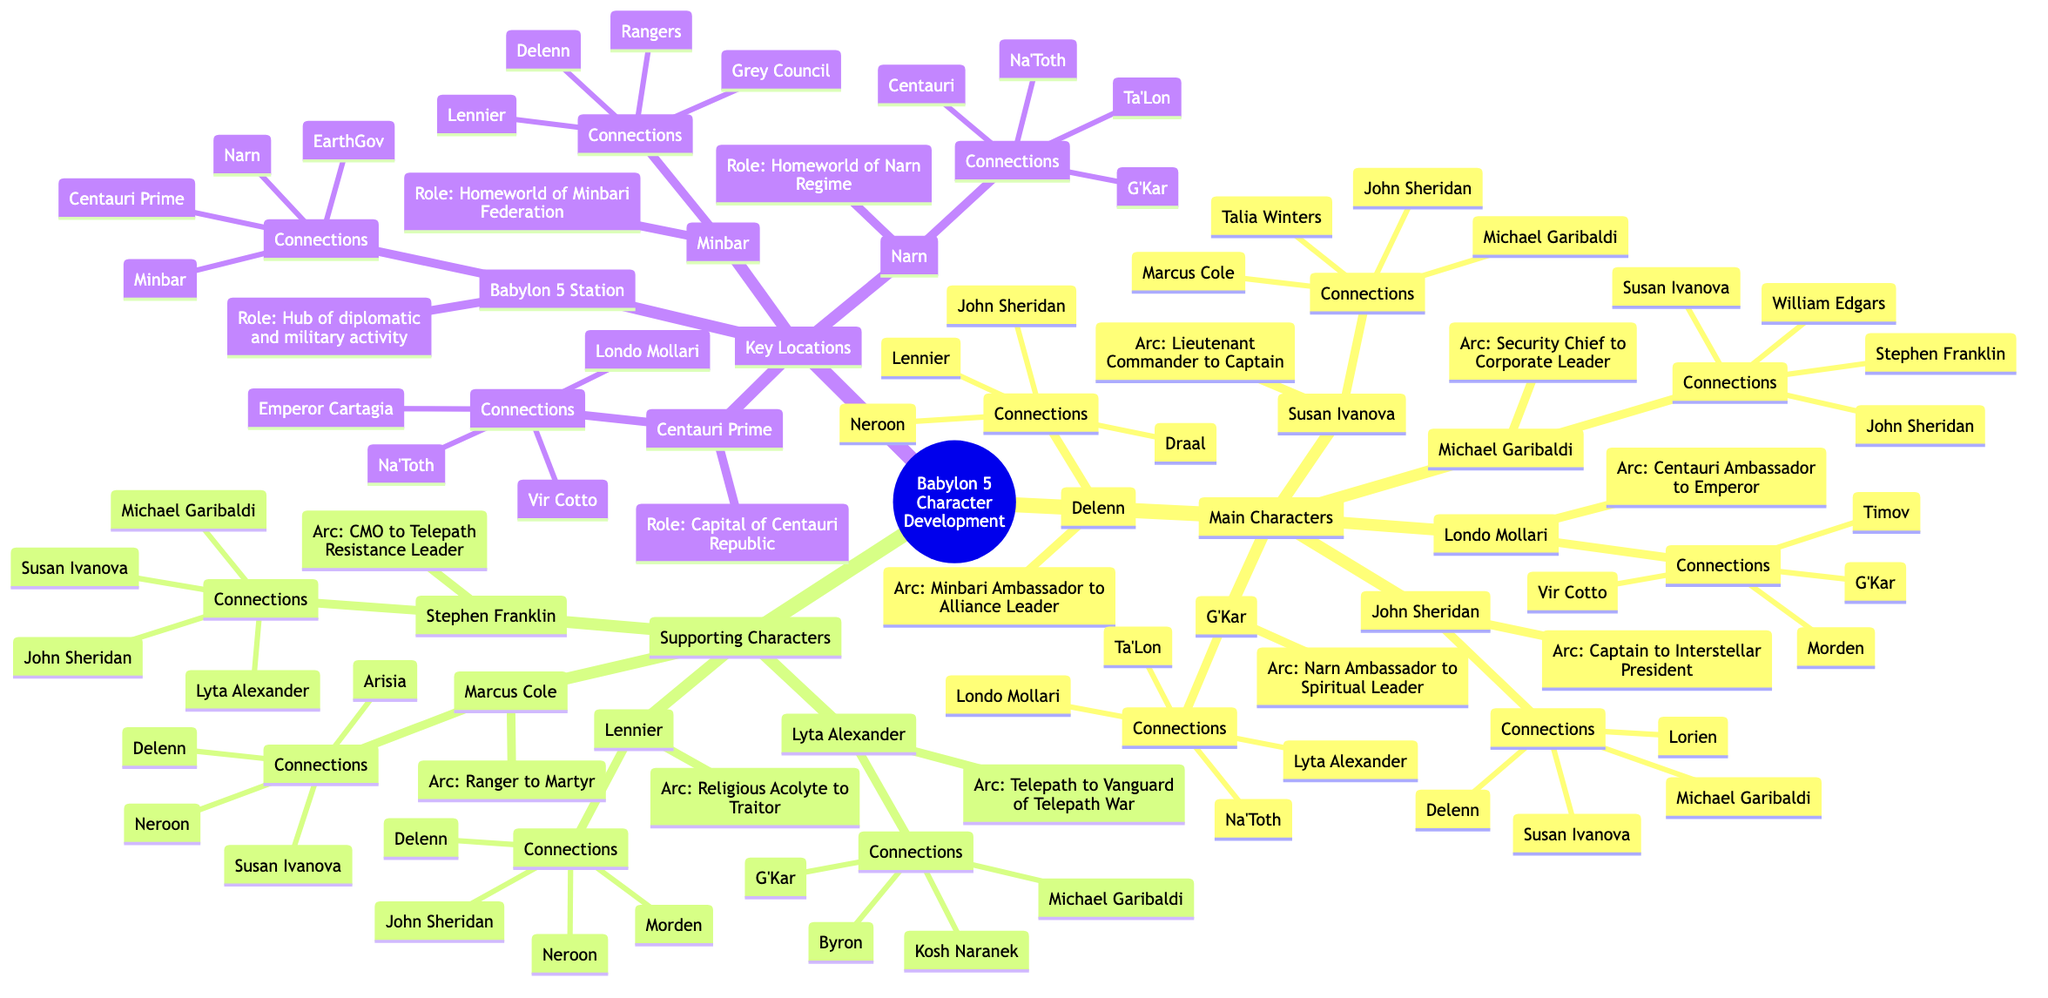What is the arc of John Sheridan? John Sheridan's arc is described as "From Captain to Interstellar President," which is indicated directly under his name in the Mind Map.
Answer: From Captain to Interstellar President How many main characters are there? The list of main characters in the diagram includes John Sheridan, Delenn, Susan Ivanova, Michael Garibaldi, G'Kar, and Londo Mollari, totaling six main characters.
Answer: 6 Who has a key connection with Stephen Franklin? Looking at the diagram, Stephen Franklin has key connections with John Sheridan, Susan Ivanova, Michael Garibaldi, and Lyta Alexander. The question refers to any one of these connections, which can be confirmed from the surrounding nodes.
Answer: John Sheridan What role does Babylon 5 Station serve? According to the diagram, the role of Babylon 5 Station is defined as "Hub of diplomatic and military activity," distinctly noted in the section.
Answer: Hub of diplomatic and military activity Which character transitions from Ranger to Martyr? The character Marcus Cole is specifically noted for his arc "Ranger to Martyr" in the Mind Map, making him the correct answer to the question.
Answer: Marcus Cole What are the connections of Delenn? By examining Delenn's node in the diagram, you can see her key connections listed as John Sheridan, Lennier, Neroon, and Draal. Hence, any of these names would qualify as an answer.
Answer: John Sheridan Who is the Centauri Ambassador to Emperor? The diagram specifies that Londo Mollari’s arc involves transitioning from "Centauri Ambassador to Emperor," capturing his character's evolution.
Answer: Londo Mollari Which supporting character is a telepath? The supporting character Lyta Alexander is identified in the diagram as transitioning from "Telepath to Vanguard of the Telepath War," confirming her telepath status.
Answer: Lyta Alexander How many characters are connected to G'Kar? G'Kar has four key connections—Londo Mollari, Lyta Alexander, Na'Toth, and Ta’Lon—which can be tracked by observing the connections listed under his node. Thus, the answer is four.
Answer: 4 What location is the homeworld of the Minbari Federation? The diagram clearly indicates that Minbar is defined as the "Homeworld of the Minbari Federation," ensuring its role is distinct and identifiable among other locations.
Answer: Minbar 